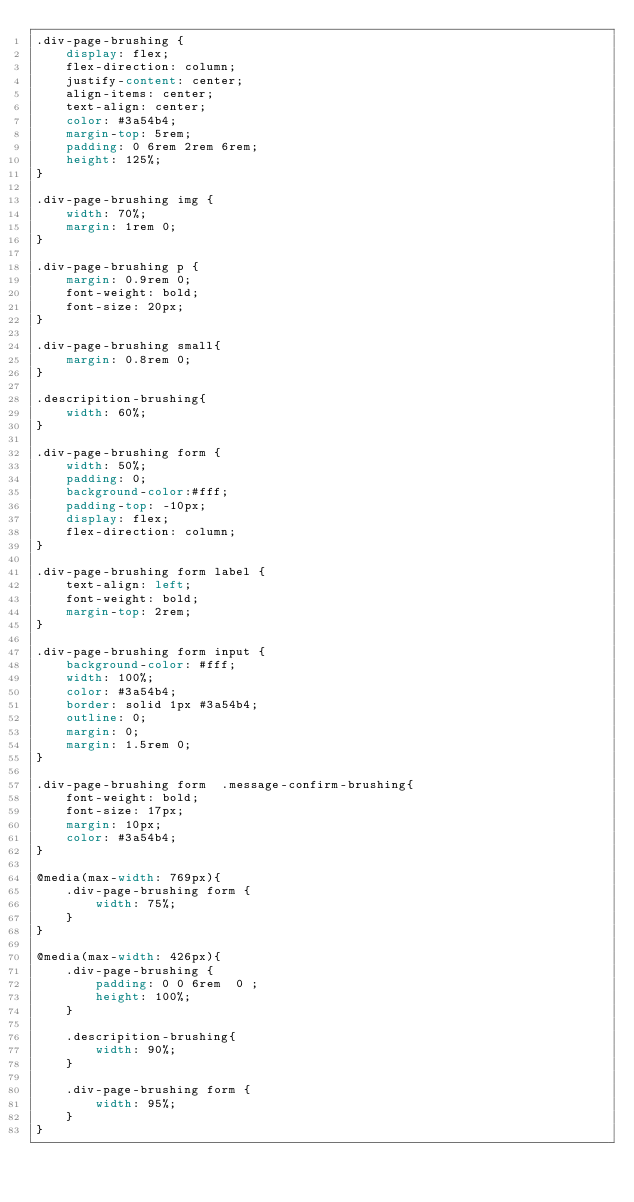<code> <loc_0><loc_0><loc_500><loc_500><_CSS_>.div-page-brushing {
    display: flex;
    flex-direction: column;
    justify-content: center;
    align-items: center;
    text-align: center;
    color: #3a54b4;
    margin-top: 5rem;
    padding: 0 6rem 2rem 6rem;
    height: 125%;
}

.div-page-brushing img {
    width: 70%;
    margin: 1rem 0;
}

.div-page-brushing p {
    margin: 0.9rem 0;
    font-weight: bold;
    font-size: 20px;
}

.div-page-brushing small{
    margin: 0.8rem 0;
}

.descripition-brushing{
    width: 60%;
}

.div-page-brushing form {
    width: 50%;
    padding: 0;
    background-color:#fff;
    padding-top: -10px;
    display: flex;
    flex-direction: column;
} 

.div-page-brushing form label {
    text-align: left;
    font-weight: bold;
    margin-top: 2rem;
}

.div-page-brushing form input {
    background-color: #fff;
    width: 100%;
    color: #3a54b4;
    border: solid 1px #3a54b4;
    outline: 0;
    margin: 0;
    margin: 1.5rem 0;
}   

.div-page-brushing form  .message-confirm-brushing{
    font-weight: bold;
    font-size: 17px;
    margin: 10px;
    color: #3a54b4;
}

@media(max-width: 769px){
    .div-page-brushing form {
        width: 75%;
    } 
}

@media(max-width: 426px){
    .div-page-brushing {
        padding: 0 0 6rem  0 ;
        height: 100%;
    }

    .descripition-brushing{
        width: 90%;
    }

    .div-page-brushing form {
        width: 95%;
    } 
}



</code> 